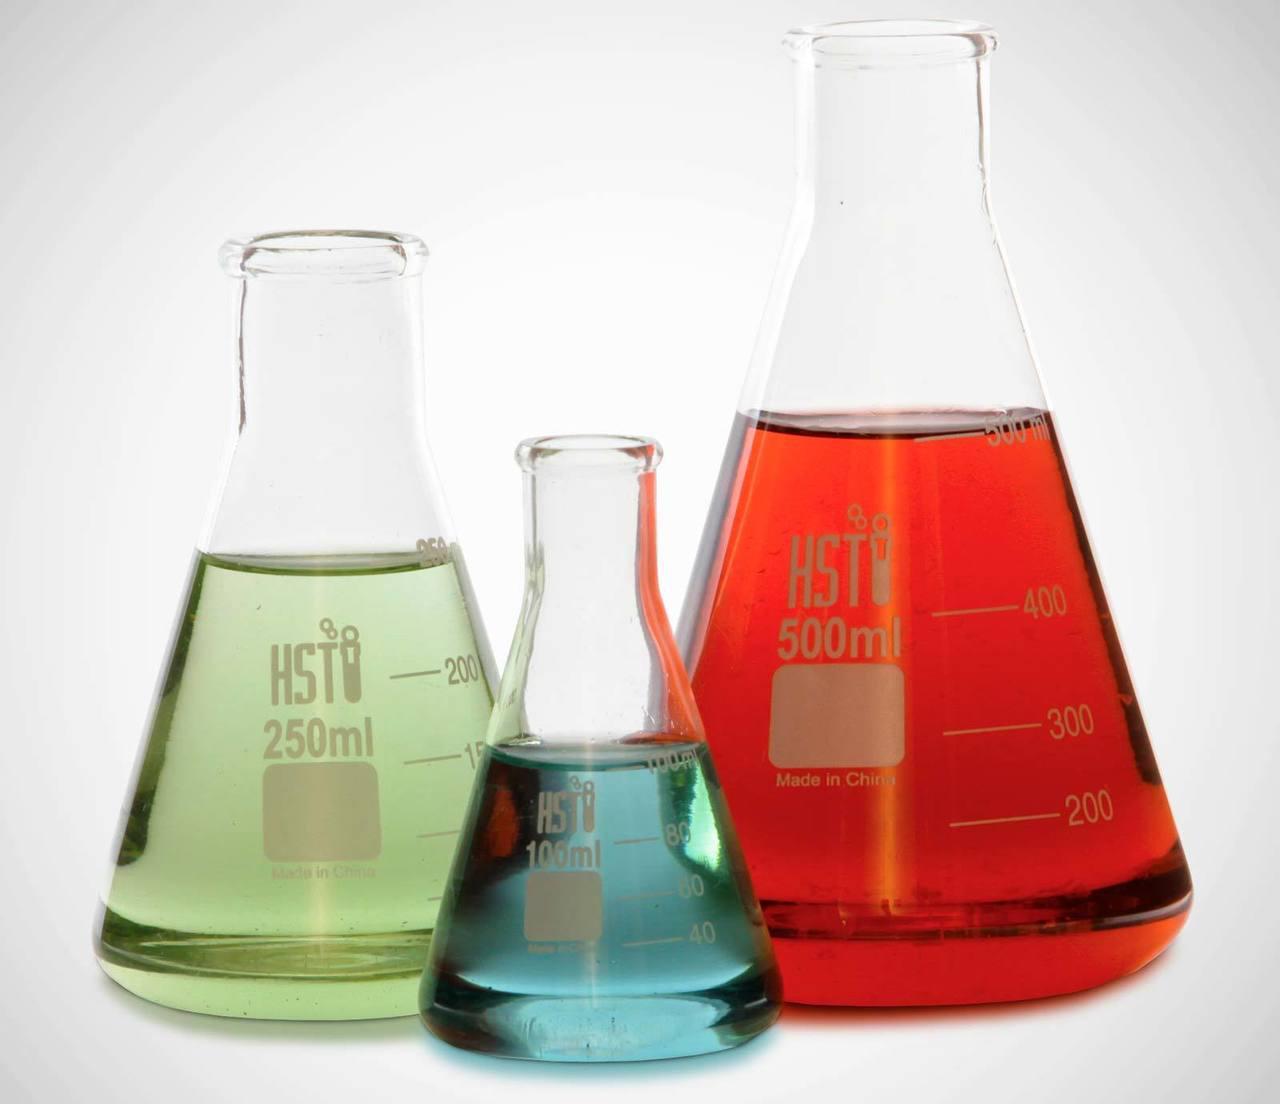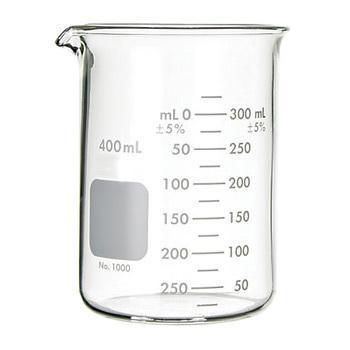The first image is the image on the left, the second image is the image on the right. Given the left and right images, does the statement "The containers in the image on the left are set up near a blue light." hold true? Answer yes or no. No. The first image is the image on the left, the second image is the image on the right. For the images displayed, is the sentence "There are exactly three object in one of the images." factually correct? Answer yes or no. Yes. 